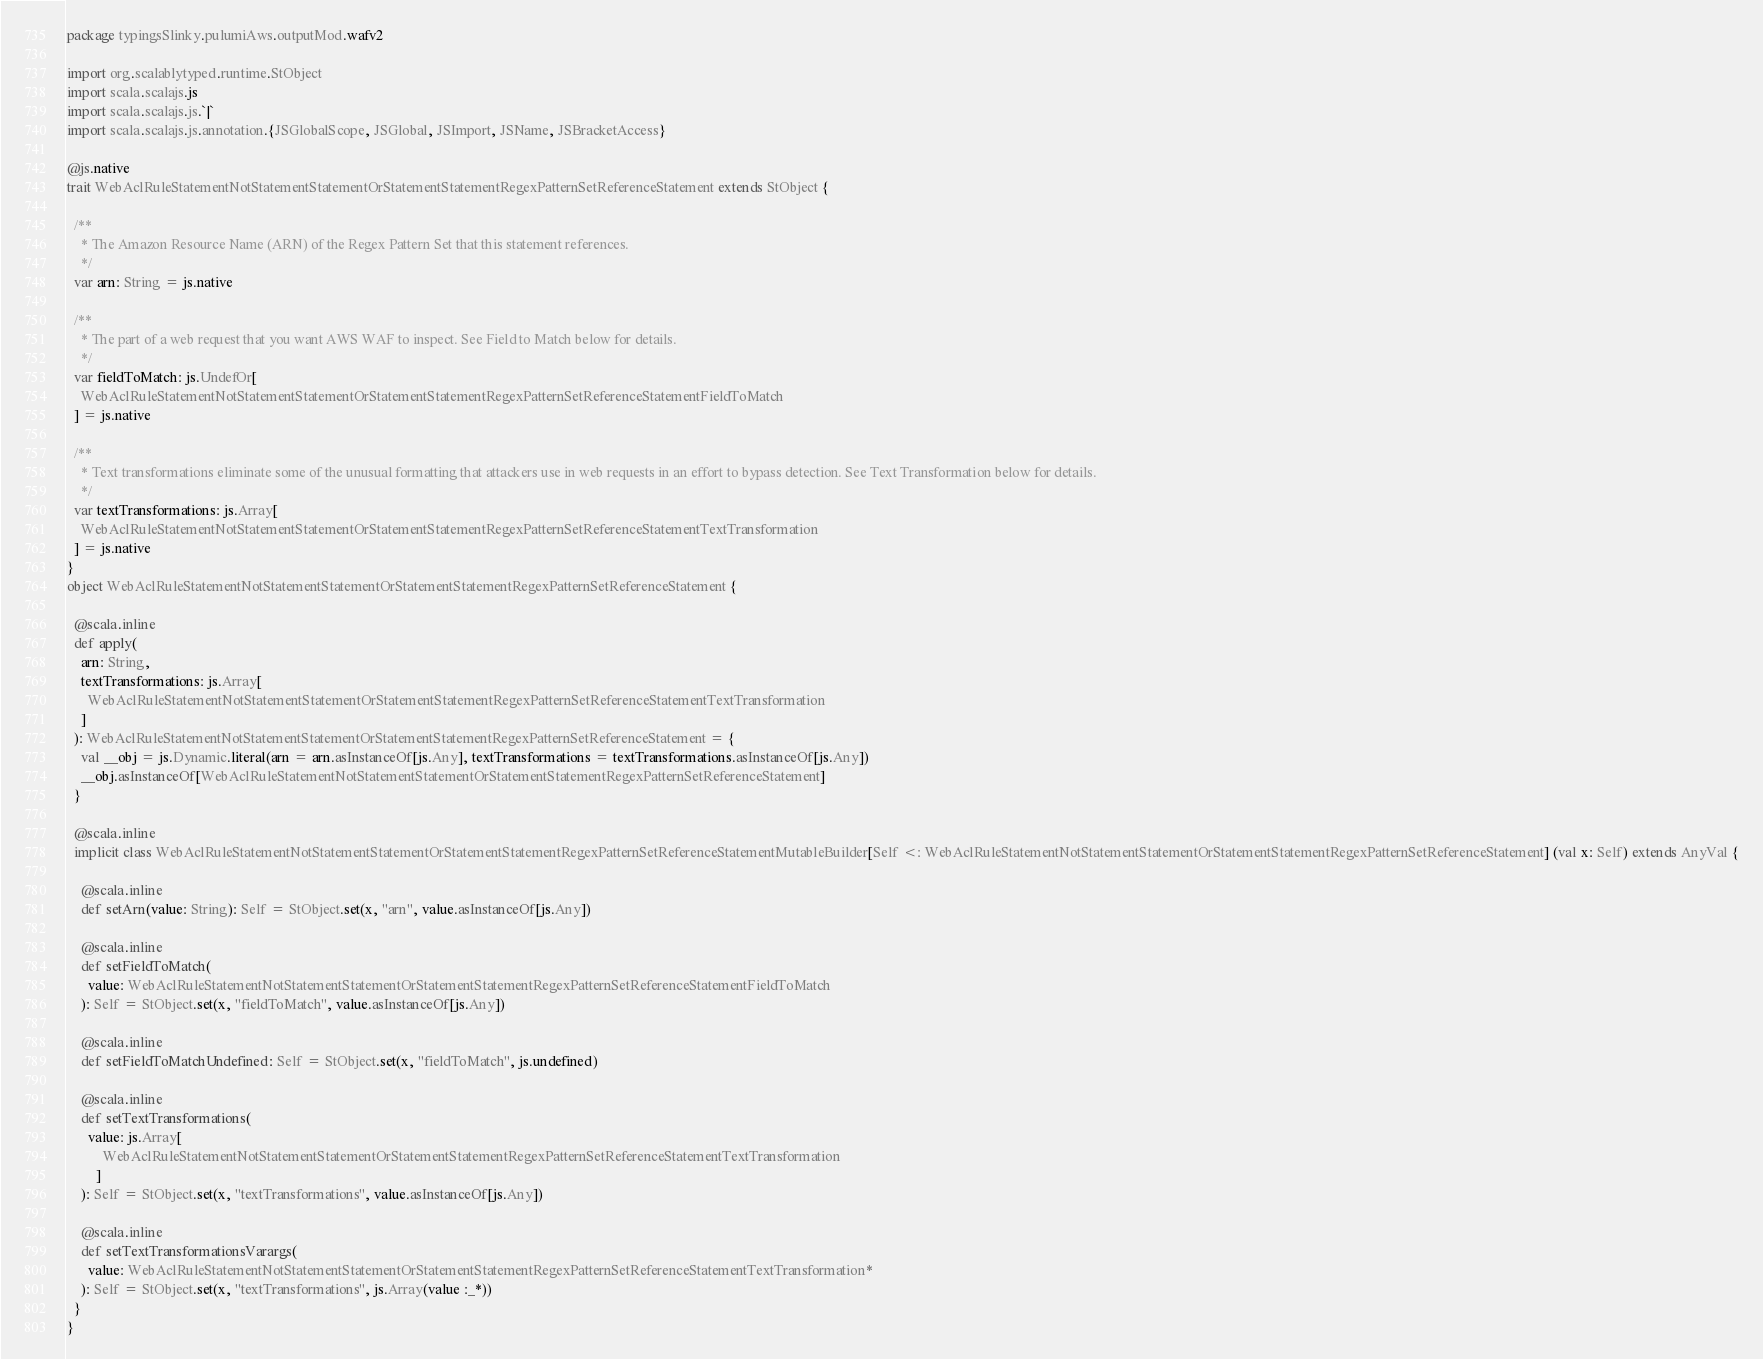<code> <loc_0><loc_0><loc_500><loc_500><_Scala_>package typingsSlinky.pulumiAws.outputMod.wafv2

import org.scalablytyped.runtime.StObject
import scala.scalajs.js
import scala.scalajs.js.`|`
import scala.scalajs.js.annotation.{JSGlobalScope, JSGlobal, JSImport, JSName, JSBracketAccess}

@js.native
trait WebAclRuleStatementNotStatementStatementOrStatementStatementRegexPatternSetReferenceStatement extends StObject {
  
  /**
    * The Amazon Resource Name (ARN) of the Regex Pattern Set that this statement references.
    */
  var arn: String = js.native
  
  /**
    * The part of a web request that you want AWS WAF to inspect. See Field to Match below for details.
    */
  var fieldToMatch: js.UndefOr[
    WebAclRuleStatementNotStatementStatementOrStatementStatementRegexPatternSetReferenceStatementFieldToMatch
  ] = js.native
  
  /**
    * Text transformations eliminate some of the unusual formatting that attackers use in web requests in an effort to bypass detection. See Text Transformation below for details.
    */
  var textTransformations: js.Array[
    WebAclRuleStatementNotStatementStatementOrStatementStatementRegexPatternSetReferenceStatementTextTransformation
  ] = js.native
}
object WebAclRuleStatementNotStatementStatementOrStatementStatementRegexPatternSetReferenceStatement {
  
  @scala.inline
  def apply(
    arn: String,
    textTransformations: js.Array[
      WebAclRuleStatementNotStatementStatementOrStatementStatementRegexPatternSetReferenceStatementTextTransformation
    ]
  ): WebAclRuleStatementNotStatementStatementOrStatementStatementRegexPatternSetReferenceStatement = {
    val __obj = js.Dynamic.literal(arn = arn.asInstanceOf[js.Any], textTransformations = textTransformations.asInstanceOf[js.Any])
    __obj.asInstanceOf[WebAclRuleStatementNotStatementStatementOrStatementStatementRegexPatternSetReferenceStatement]
  }
  
  @scala.inline
  implicit class WebAclRuleStatementNotStatementStatementOrStatementStatementRegexPatternSetReferenceStatementMutableBuilder[Self <: WebAclRuleStatementNotStatementStatementOrStatementStatementRegexPatternSetReferenceStatement] (val x: Self) extends AnyVal {
    
    @scala.inline
    def setArn(value: String): Self = StObject.set(x, "arn", value.asInstanceOf[js.Any])
    
    @scala.inline
    def setFieldToMatch(
      value: WebAclRuleStatementNotStatementStatementOrStatementStatementRegexPatternSetReferenceStatementFieldToMatch
    ): Self = StObject.set(x, "fieldToMatch", value.asInstanceOf[js.Any])
    
    @scala.inline
    def setFieldToMatchUndefined: Self = StObject.set(x, "fieldToMatch", js.undefined)
    
    @scala.inline
    def setTextTransformations(
      value: js.Array[
          WebAclRuleStatementNotStatementStatementOrStatementStatementRegexPatternSetReferenceStatementTextTransformation
        ]
    ): Self = StObject.set(x, "textTransformations", value.asInstanceOf[js.Any])
    
    @scala.inline
    def setTextTransformationsVarargs(
      value: WebAclRuleStatementNotStatementStatementOrStatementStatementRegexPatternSetReferenceStatementTextTransformation*
    ): Self = StObject.set(x, "textTransformations", js.Array(value :_*))
  }
}
</code> 